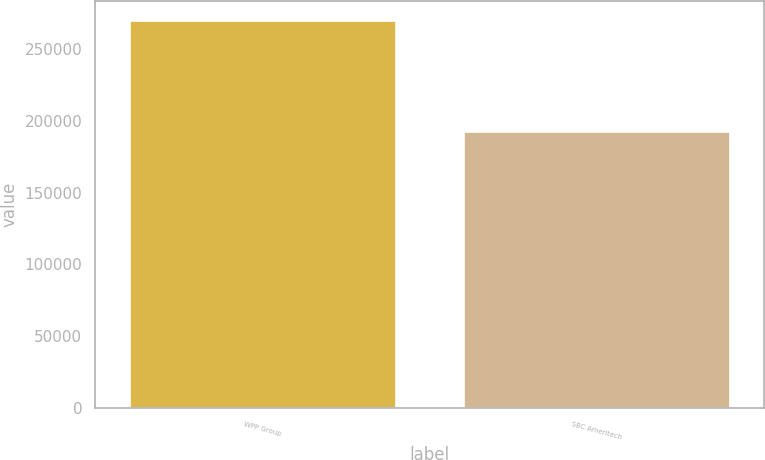Convert chart. <chart><loc_0><loc_0><loc_500><loc_500><bar_chart><fcel>WPP Group<fcel>SBC Ameritech<nl><fcel>270000<fcel>193000<nl></chart> 